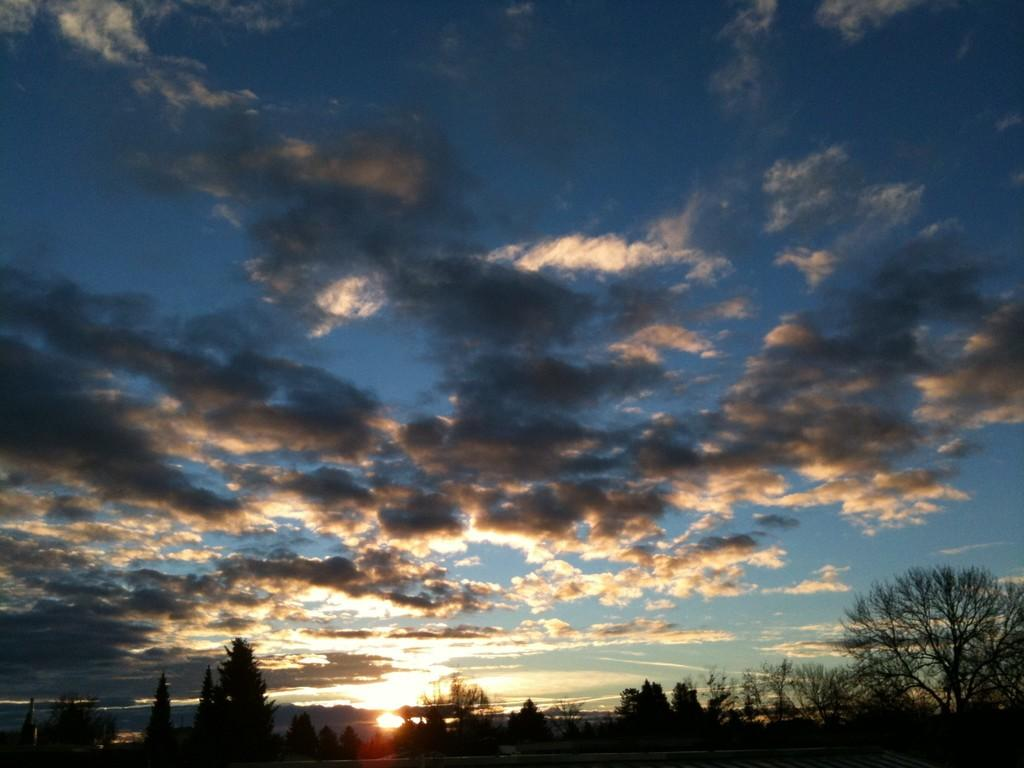What is located in the center of the image? There are trees in the center of the image. How would you describe the sky in the image? The sky is cloudy in the image. What type of beast can be seen roaming in the image? There is no beast present in the image; it only features trees and a cloudy sky. What month is depicted in the image? The image does not depict a specific month; it only shows trees and a cloudy sky. 